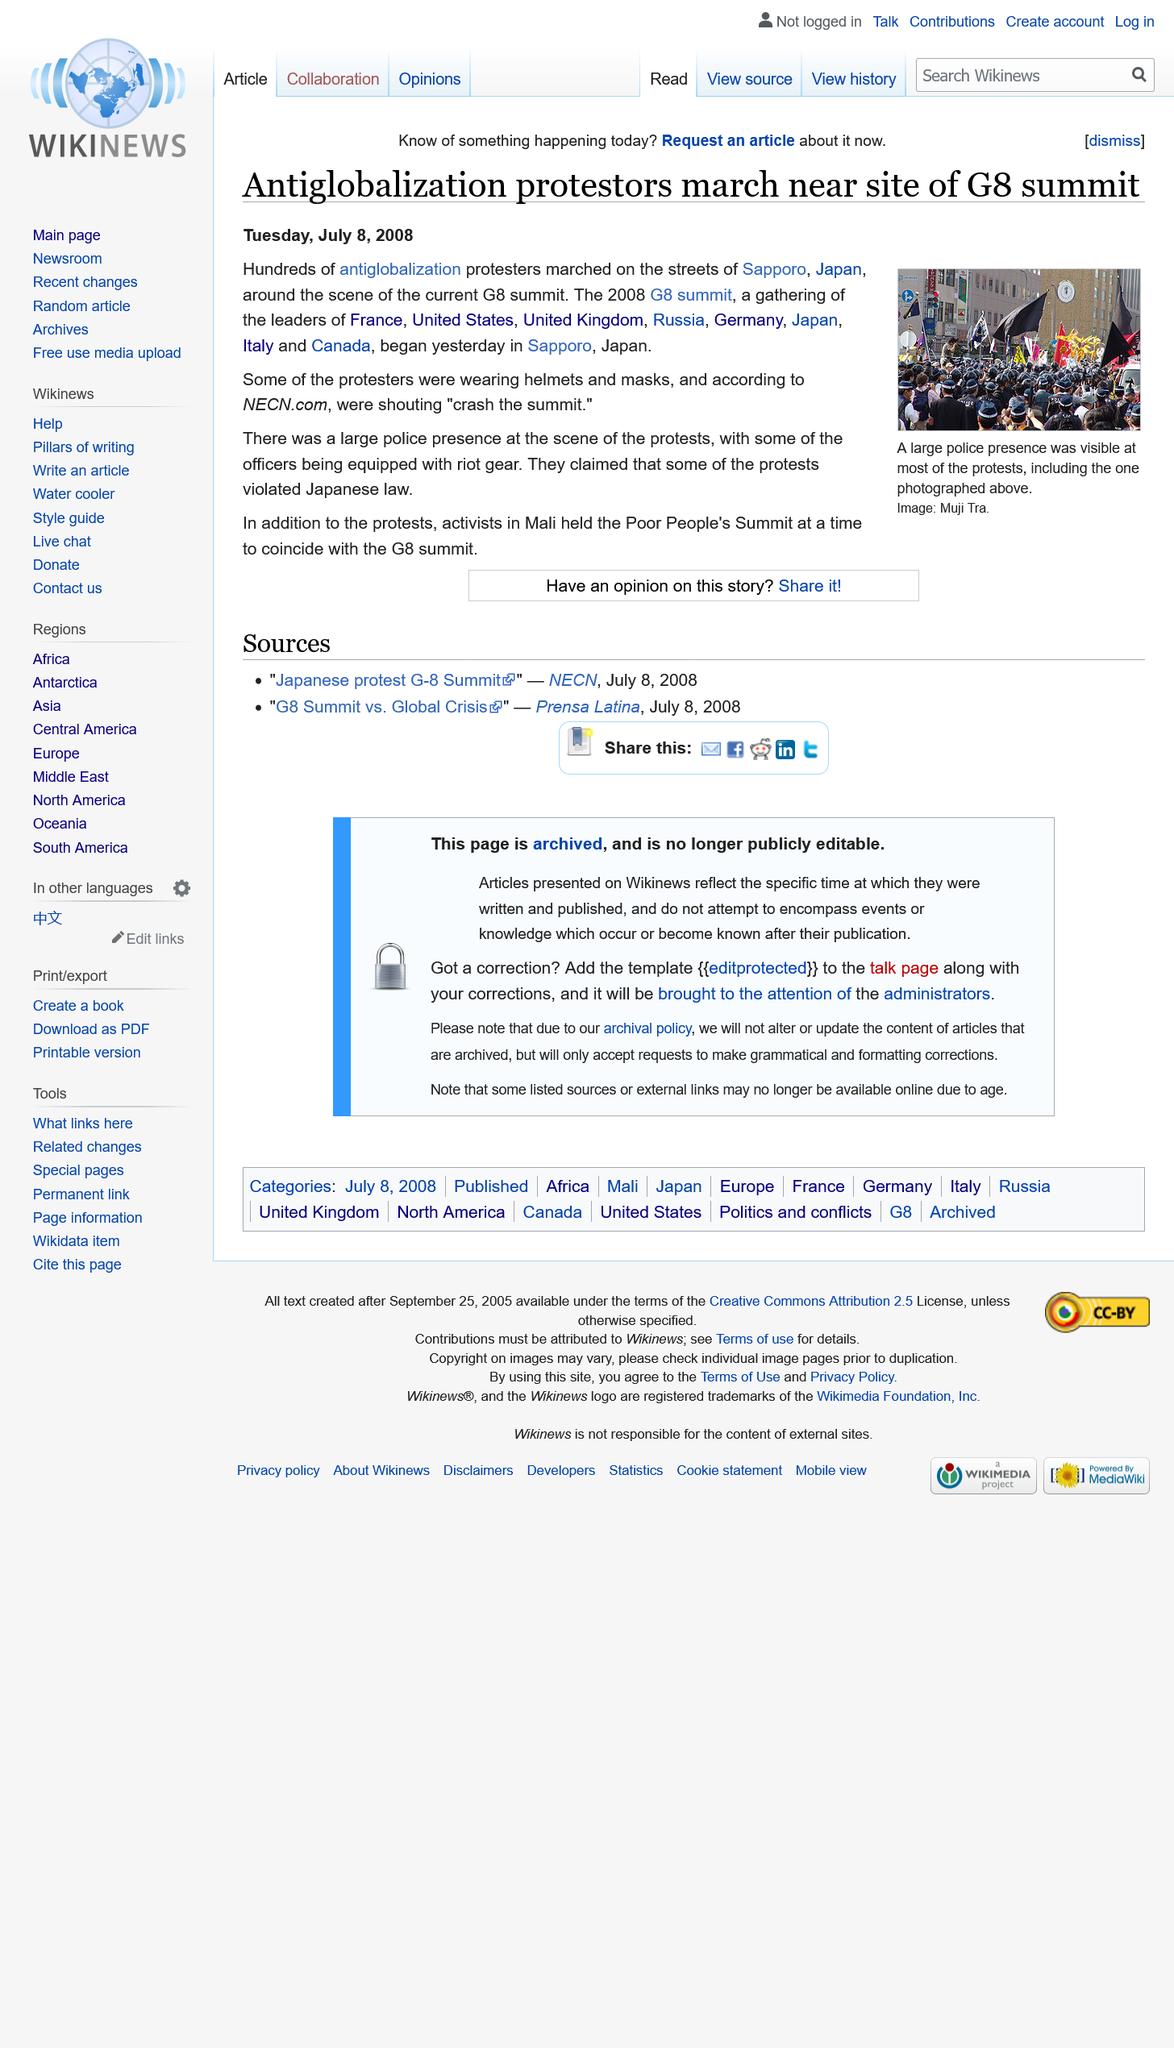Point out several critical features in this image. Activists in Mali held the Poor People's Summit in conjunction with the G8 summit to address the needs and concerns of marginalized communities. The 2008 G8 summit was attended by representatives from France, the United States, the United Kingdom, Russia, Germany, Japan, Italy, and Canada. During the 2008 G8 summit, hundreds of anti-globalization protesters marched in Sapporo, Japan. 